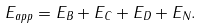<formula> <loc_0><loc_0><loc_500><loc_500>E _ { a p p } = E _ { B } + E _ { C } + E _ { D } + E _ { N } .</formula> 